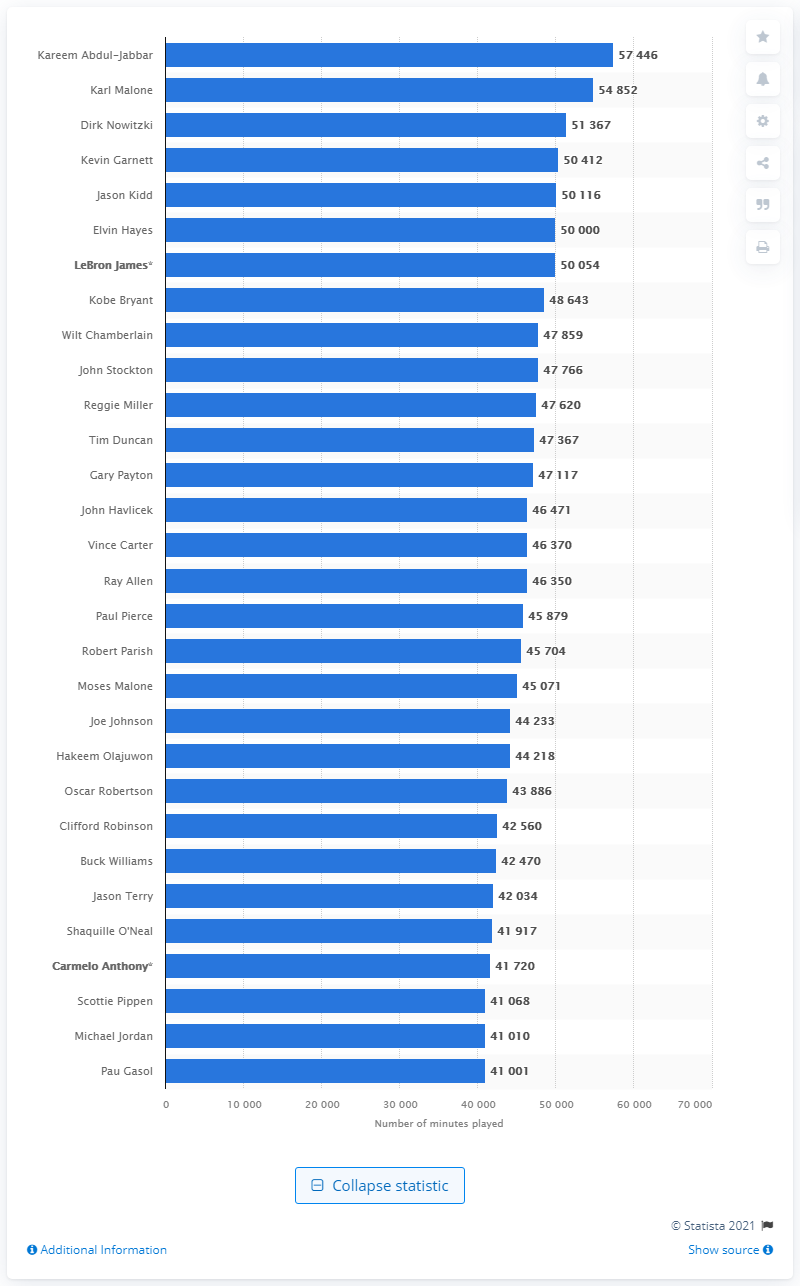Specify some key components in this picture. Kareem Abdul-Jabbar, the player with the highest number of minutes on the court, is the most experienced player on the court. 